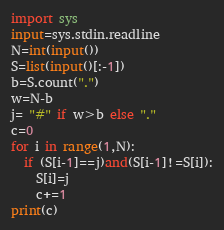Convert code to text. <code><loc_0><loc_0><loc_500><loc_500><_Python_>import sys
input=sys.stdin.readline
N=int(input())
S=list(input()[:-1])
b=S.count(".")
w=N-b
j= "#" if w>b else "."
c=0
for i in range(1,N):
  if (S[i-1]==j)and(S[i-1]!=S[i]):
    S[i]=j
    c+=1
print(c)</code> 